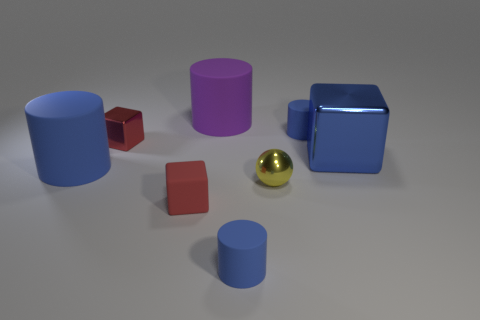Subtract all cyan cubes. How many blue cylinders are left? 3 Add 1 tiny purple matte objects. How many objects exist? 9 Subtract all cubes. How many objects are left? 5 Subtract all big blue shiny objects. Subtract all small blue matte cylinders. How many objects are left? 5 Add 2 yellow spheres. How many yellow spheres are left? 3 Add 2 rubber cylinders. How many rubber cylinders exist? 6 Subtract 0 brown cubes. How many objects are left? 8 